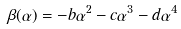Convert formula to latex. <formula><loc_0><loc_0><loc_500><loc_500>\beta ( \alpha ) = - b \alpha ^ { 2 } - c \alpha ^ { 3 } - d \alpha ^ { 4 }</formula> 